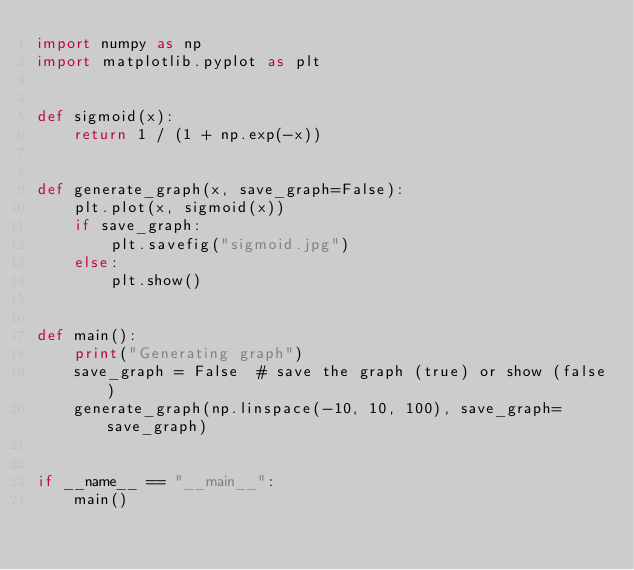<code> <loc_0><loc_0><loc_500><loc_500><_Python_>import numpy as np
import matplotlib.pyplot as plt


def sigmoid(x):
    return 1 / (1 + np.exp(-x))


def generate_graph(x, save_graph=False):
    plt.plot(x, sigmoid(x))
    if save_graph:
        plt.savefig("sigmoid.jpg")
    else:
        plt.show()


def main():
    print("Generating graph")
    save_graph = False  # save the graph (true) or show (false)
    generate_graph(np.linspace(-10, 10, 100), save_graph=save_graph)


if __name__ == "__main__":
    main()
</code> 